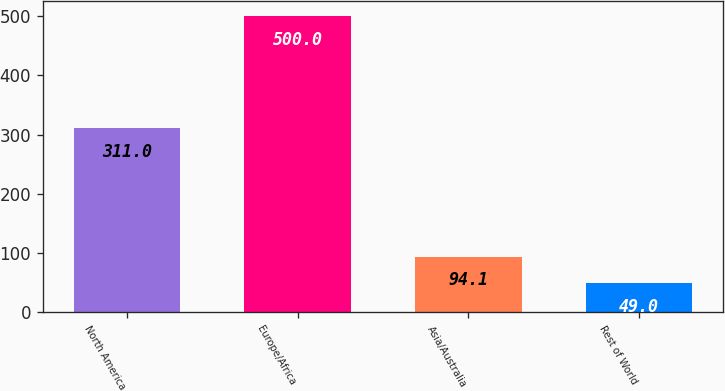Convert chart. <chart><loc_0><loc_0><loc_500><loc_500><bar_chart><fcel>North America<fcel>Europe/Africa<fcel>Asia/Australia<fcel>Rest of World<nl><fcel>311<fcel>500<fcel>94.1<fcel>49<nl></chart> 